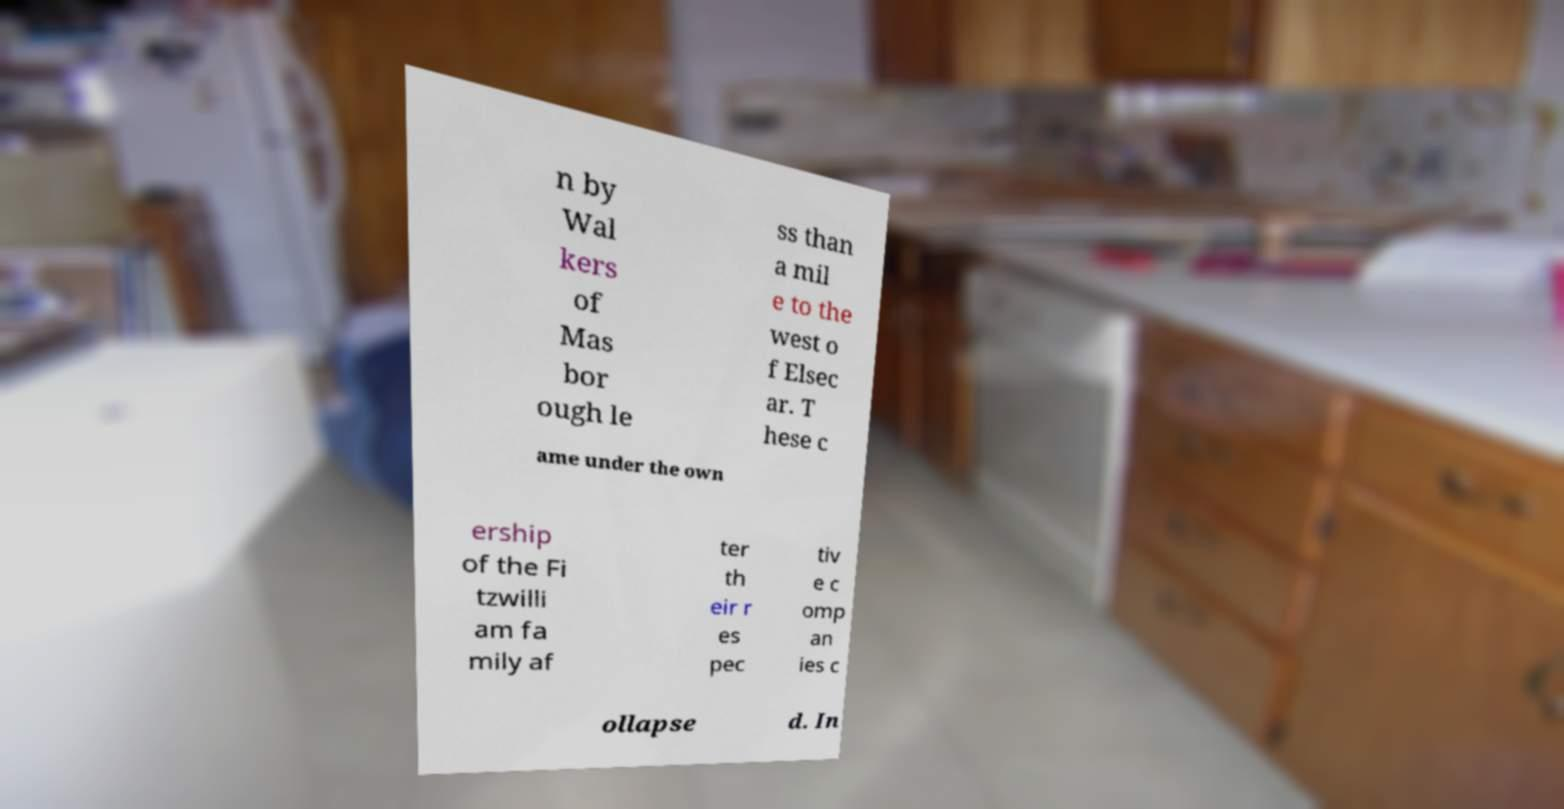Please identify and transcribe the text found in this image. n by Wal kers of Mas bor ough le ss than a mil e to the west o f Elsec ar. T hese c ame under the own ership of the Fi tzwilli am fa mily af ter th eir r es pec tiv e c omp an ies c ollapse d. In 